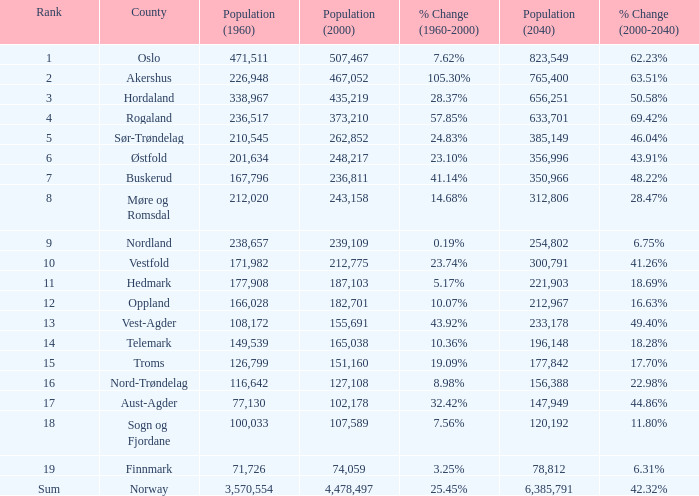What was Oslo's population in 1960, with a population of 507,467 in 2000? None. 